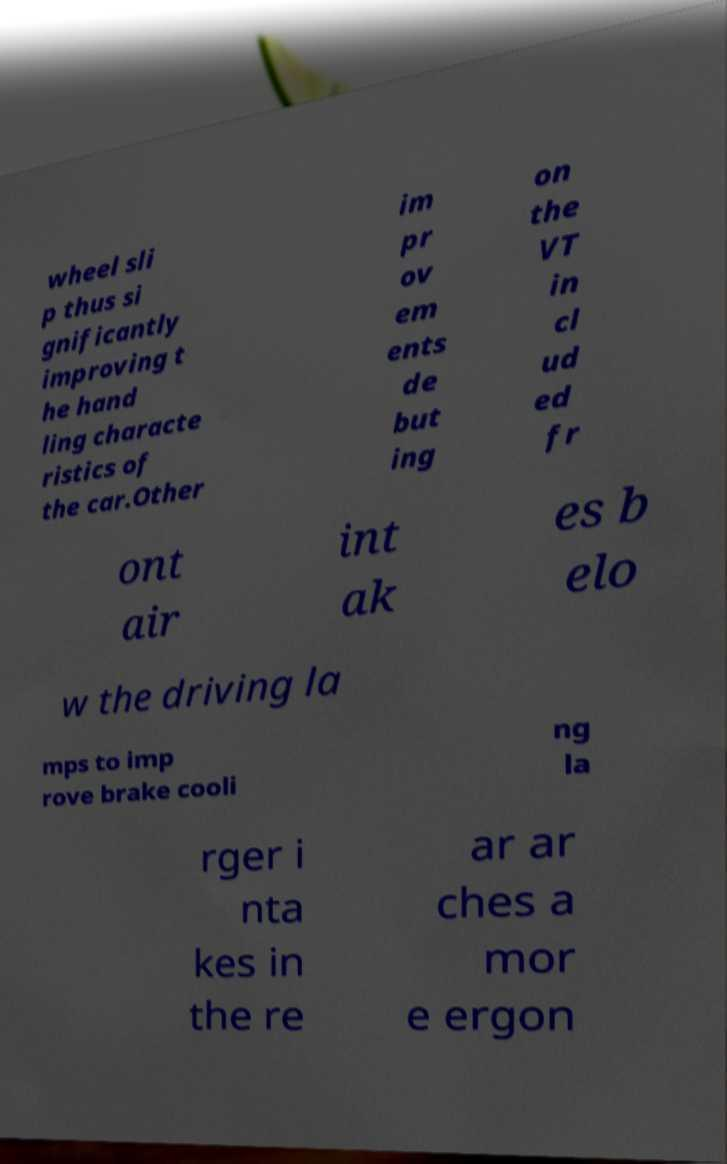Please read and relay the text visible in this image. What does it say? wheel sli p thus si gnificantly improving t he hand ling characte ristics of the car.Other im pr ov em ents de but ing on the VT in cl ud ed fr ont air int ak es b elo w the driving la mps to imp rove brake cooli ng la rger i nta kes in the re ar ar ches a mor e ergon 